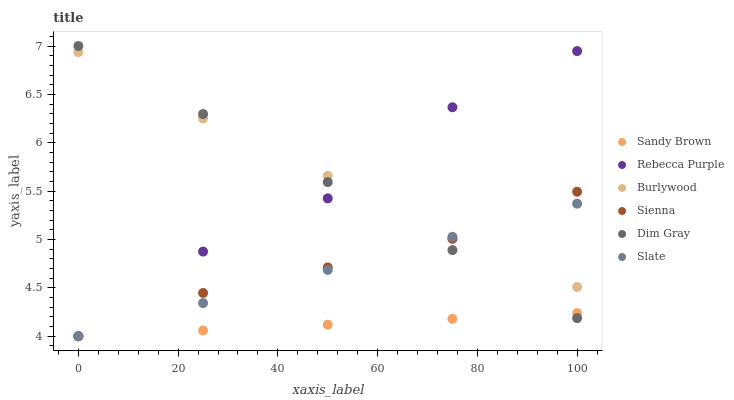Does Sandy Brown have the minimum area under the curve?
Answer yes or no. Yes. Does Burlywood have the maximum area under the curve?
Answer yes or no. Yes. Does Slate have the minimum area under the curve?
Answer yes or no. No. Does Slate have the maximum area under the curve?
Answer yes or no. No. Is Dim Gray the smoothest?
Answer yes or no. Yes. Is Rebecca Purple the roughest?
Answer yes or no. Yes. Is Burlywood the smoothest?
Answer yes or no. No. Is Burlywood the roughest?
Answer yes or no. No. Does Slate have the lowest value?
Answer yes or no. Yes. Does Burlywood have the lowest value?
Answer yes or no. No. Does Dim Gray have the highest value?
Answer yes or no. Yes. Does Burlywood have the highest value?
Answer yes or no. No. Is Sandy Brown less than Burlywood?
Answer yes or no. Yes. Is Burlywood greater than Sandy Brown?
Answer yes or no. Yes. Does Slate intersect Dim Gray?
Answer yes or no. Yes. Is Slate less than Dim Gray?
Answer yes or no. No. Is Slate greater than Dim Gray?
Answer yes or no. No. Does Sandy Brown intersect Burlywood?
Answer yes or no. No. 